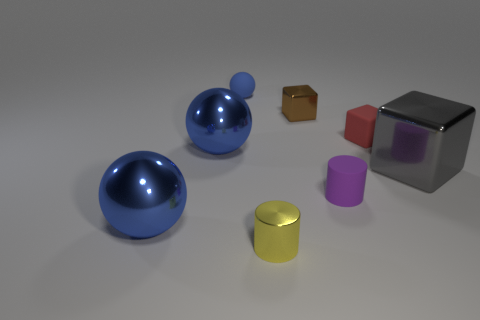Subtract all large shiny spheres. How many spheres are left? 1 Add 1 small spheres. How many objects exist? 9 Subtract all cubes. How many objects are left? 5 Add 6 small yellow metal cubes. How many small yellow metal cubes exist? 6 Subtract 0 cyan blocks. How many objects are left? 8 Subtract all green metallic cylinders. Subtract all large blue objects. How many objects are left? 6 Add 6 yellow cylinders. How many yellow cylinders are left? 7 